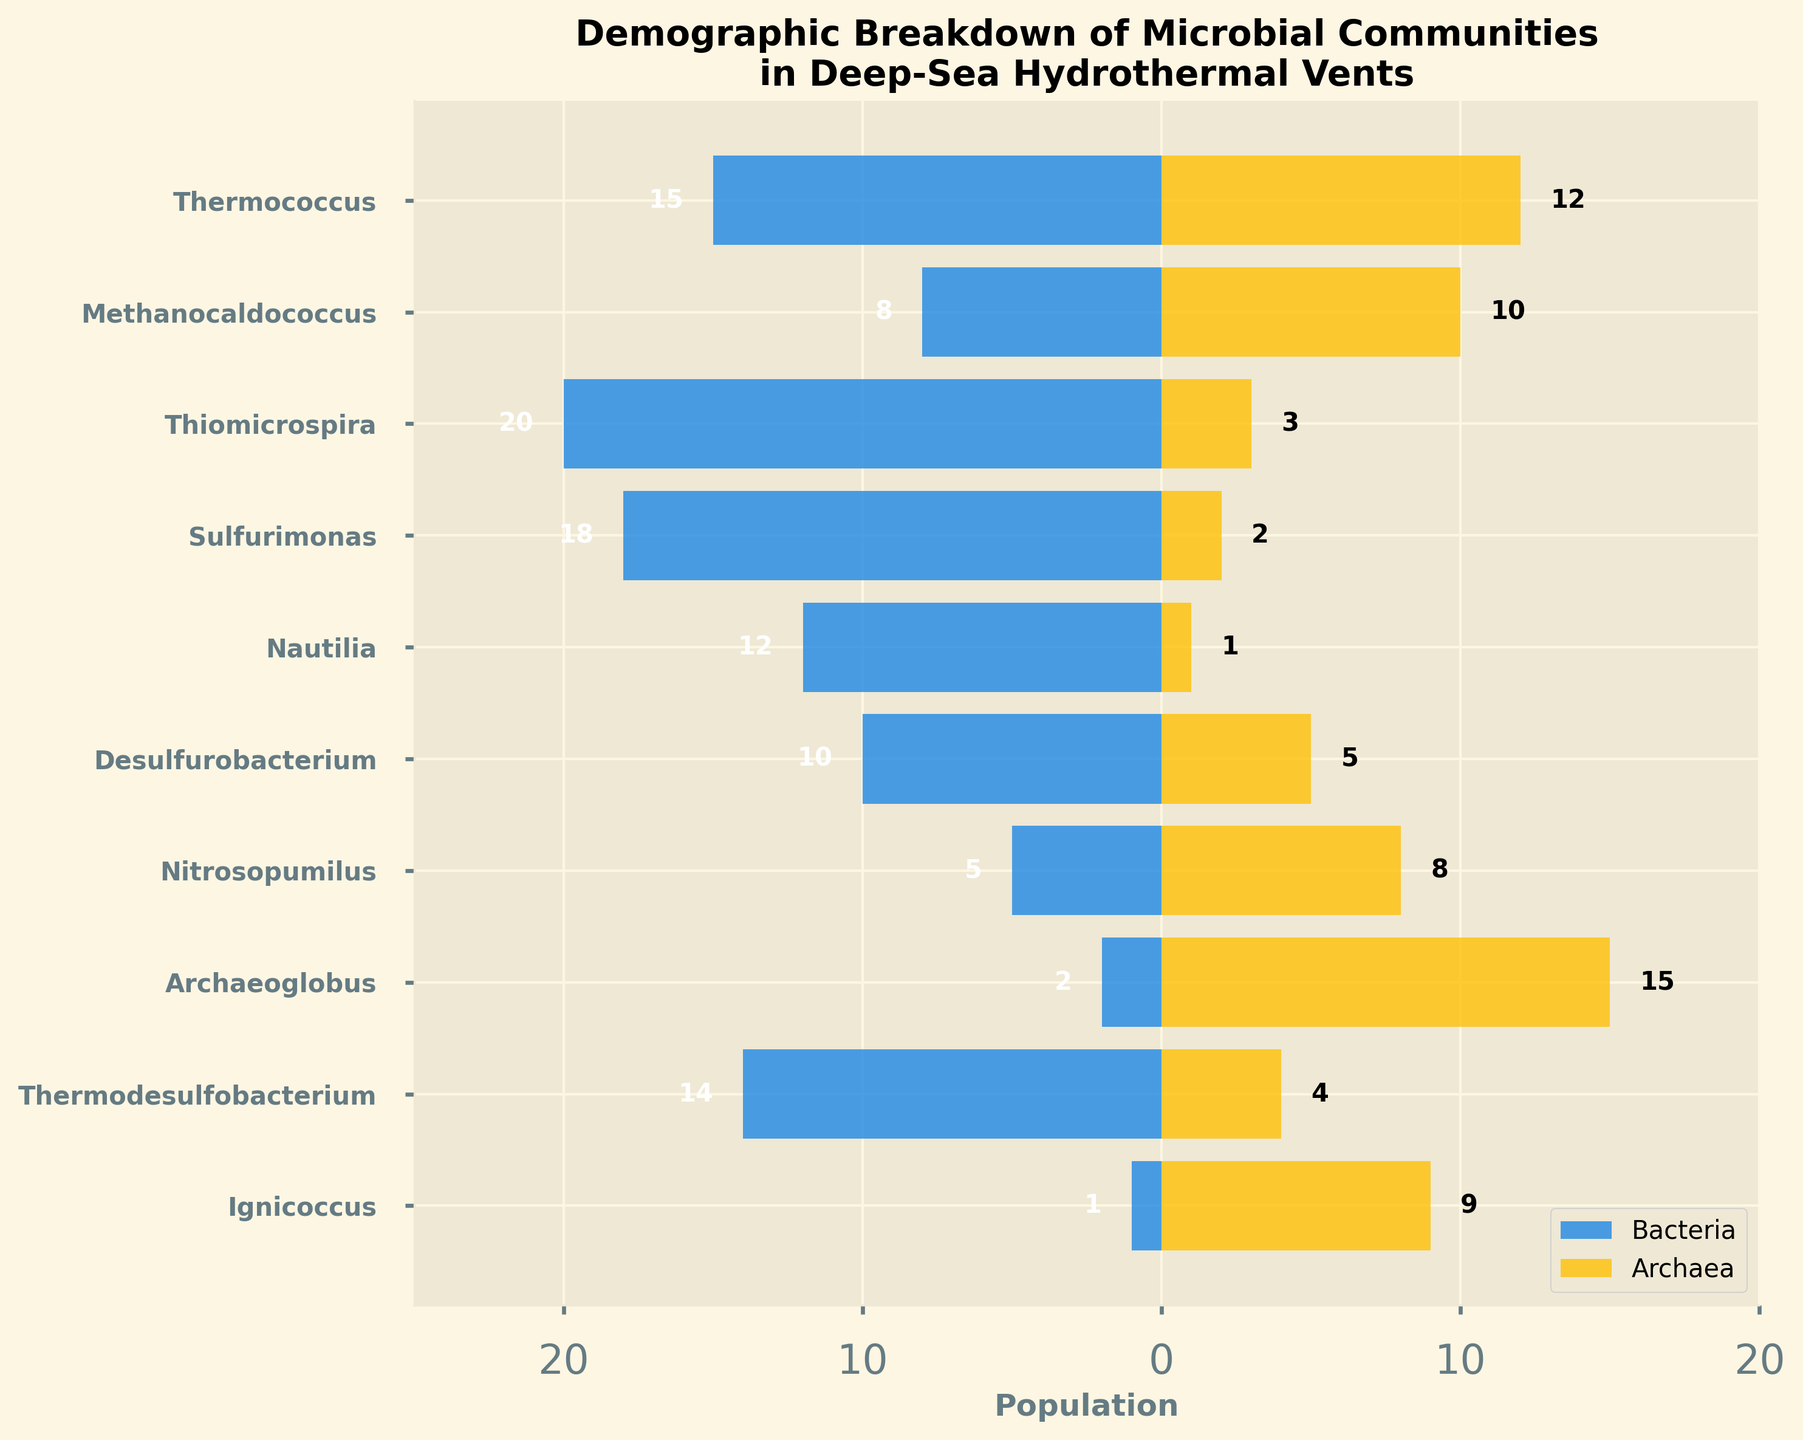What is the title of the figure? The title of the figure is located at the top and it provides a summary of the plot's overall message. The title reads "Demographic Breakdown of Microbial Communities in Deep-Sea Hydrothermal Vents".
Answer: Demographic Breakdown of Microbial Communities in Deep-Sea Hydrothermal Vents Which microbial category has the highest population of Archaea? Look at the Archaea bars in the plot. The category with the longest bar to the right represents the highest population. The Archaea population is highest in "Archaeoglobus".
Answer: Archaeoglobus Which categories have a higher population of Archaea compared to Bacteria? Compare the lengths of the bars for each category to see if the Archaea bar (right side) is longer than the Bacteria bar (left side). Categories with higher Archaea populations are: Thermococcus, Methanocaldococcus, Nitrosopumilus, Archaeoglobus, Ignicoccus.
Answer: Thermococcus, Methanocaldococcus, Nitrosopumilus, Archaeoglobus, Ignicoccus How many categories have more than 10 units of Bacteria? Count the number of bars on the left (Bacteria) that extend to -10 or more (to the left). Categories include: Thermococcus, Thiomicrospira, Sulfurimonas, Nautilia, Thermodesulfobacterium.
Answer: 5 What is the median population of the Bacteria categories? Sort the Bacteria populations and find the middle value. Sorted Bacteria populations: -20, -18, -15, -14, -12, -10, -8, -5, -2, -1. The median of this sorted list is the average of the two middle values (-12 and -10): ( -12 + -10 ) / 2 = -11.
Answer: -11 How does the population of Archaea in Ignicoccus compare to that in Methanocaldococcus? Locate Ignicoccus and Methanocaldococcus on the plot. Ignicoccus has 9 units of Archaea, while Methanocaldococcus has 10. Compare these values: Methanocaldococcus > Ignicoccus by 1 unit.
Answer: Methanocaldococcus has 1 unit more than Ignicoccus 